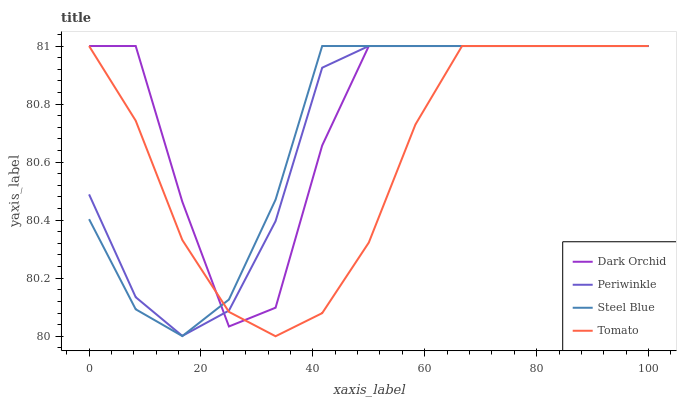Does Tomato have the minimum area under the curve?
Answer yes or no. Yes. Does Dark Orchid have the maximum area under the curve?
Answer yes or no. Yes. Does Periwinkle have the minimum area under the curve?
Answer yes or no. No. Does Periwinkle have the maximum area under the curve?
Answer yes or no. No. Is Steel Blue the smoothest?
Answer yes or no. Yes. Is Dark Orchid the roughest?
Answer yes or no. Yes. Is Periwinkle the smoothest?
Answer yes or no. No. Is Periwinkle the roughest?
Answer yes or no. No. Does Tomato have the lowest value?
Answer yes or no. Yes. Does Periwinkle have the lowest value?
Answer yes or no. No. Does Dark Orchid have the highest value?
Answer yes or no. Yes. Does Steel Blue intersect Dark Orchid?
Answer yes or no. Yes. Is Steel Blue less than Dark Orchid?
Answer yes or no. No. Is Steel Blue greater than Dark Orchid?
Answer yes or no. No. 